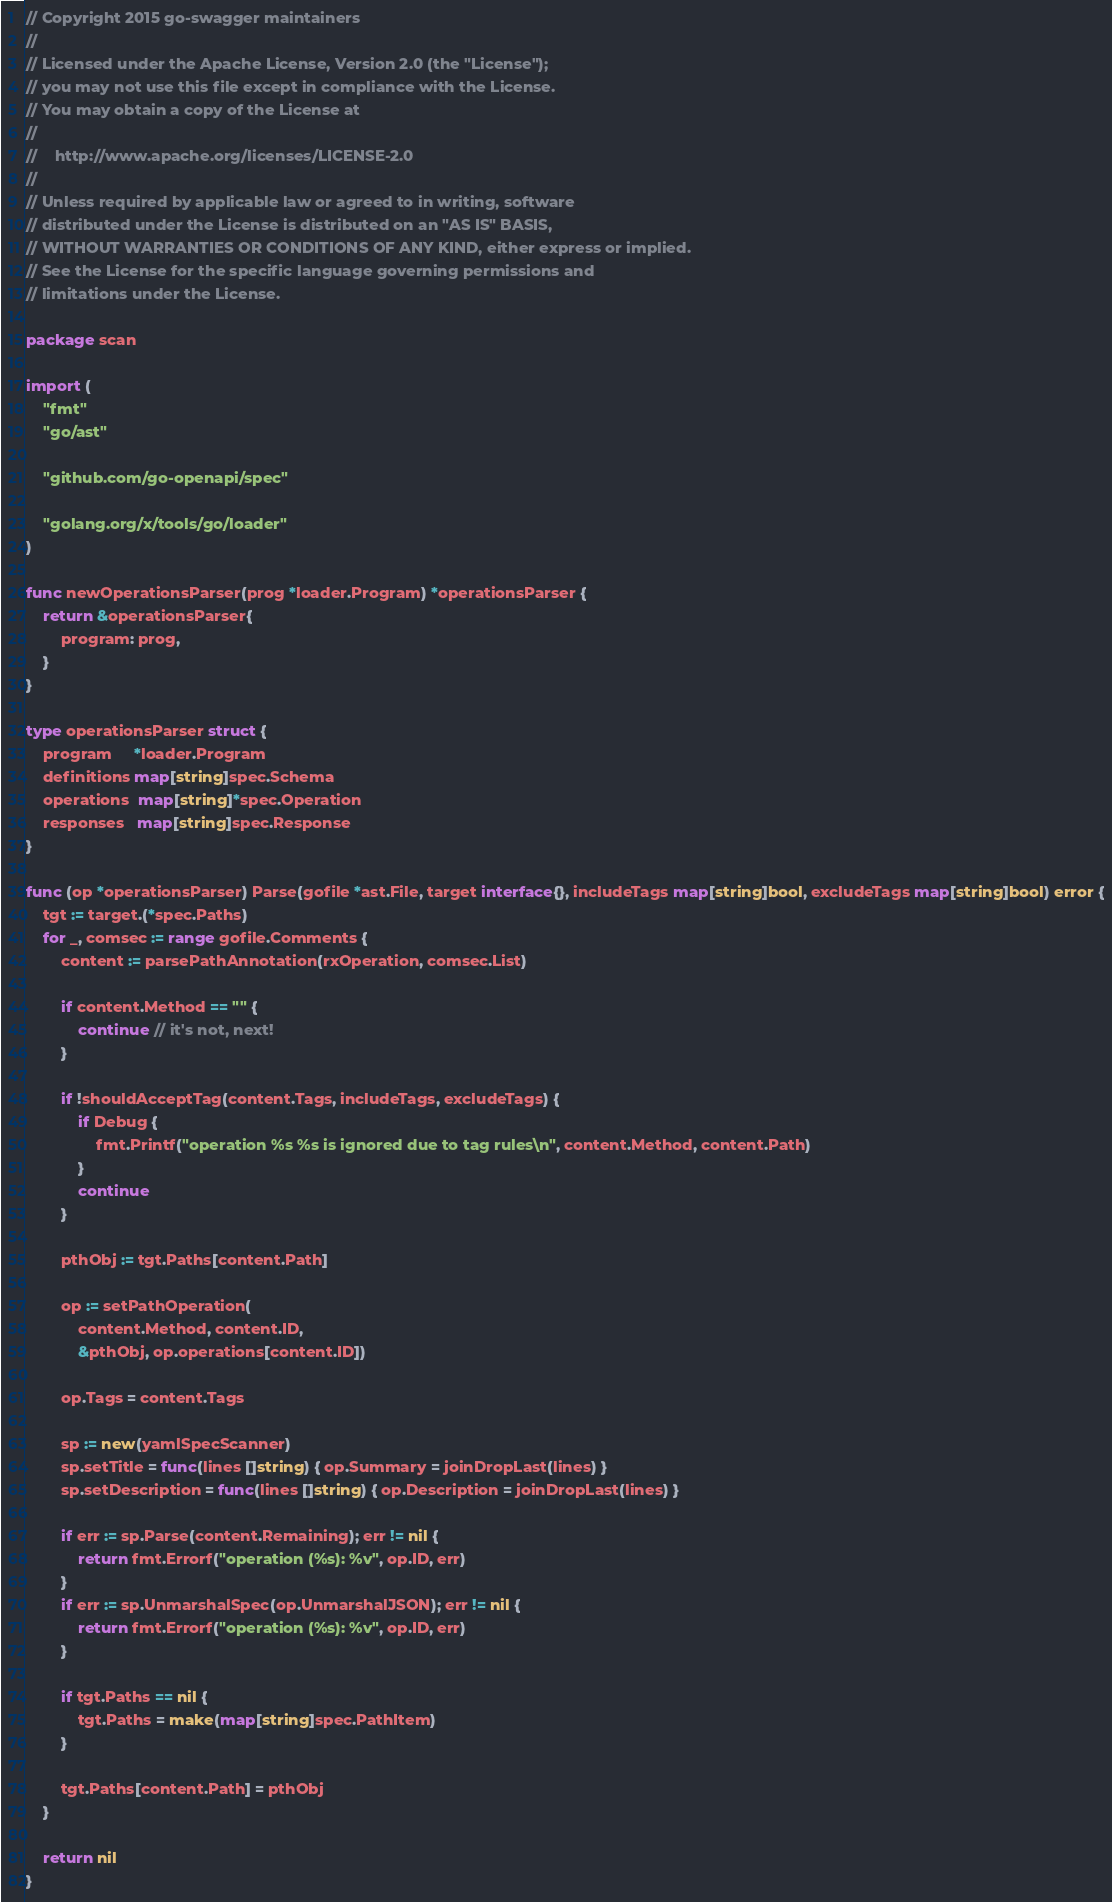<code> <loc_0><loc_0><loc_500><loc_500><_Go_>// Copyright 2015 go-swagger maintainers
//
// Licensed under the Apache License, Version 2.0 (the "License");
// you may not use this file except in compliance with the License.
// You may obtain a copy of the License at
//
//    http://www.apache.org/licenses/LICENSE-2.0
//
// Unless required by applicable law or agreed to in writing, software
// distributed under the License is distributed on an "AS IS" BASIS,
// WITHOUT WARRANTIES OR CONDITIONS OF ANY KIND, either express or implied.
// See the License for the specific language governing permissions and
// limitations under the License.

package scan

import (
	"fmt"
	"go/ast"

	"github.com/go-openapi/spec"

	"golang.org/x/tools/go/loader"
)

func newOperationsParser(prog *loader.Program) *operationsParser {
	return &operationsParser{
		program: prog,
	}
}

type operationsParser struct {
	program     *loader.Program
	definitions map[string]spec.Schema
	operations  map[string]*spec.Operation
	responses   map[string]spec.Response
}

func (op *operationsParser) Parse(gofile *ast.File, target interface{}, includeTags map[string]bool, excludeTags map[string]bool) error {
	tgt := target.(*spec.Paths)
	for _, comsec := range gofile.Comments {
		content := parsePathAnnotation(rxOperation, comsec.List)

		if content.Method == "" {
			continue // it's not, next!
		}

		if !shouldAcceptTag(content.Tags, includeTags, excludeTags) {
			if Debug {
				fmt.Printf("operation %s %s is ignored due to tag rules\n", content.Method, content.Path)
			}
			continue
		}

		pthObj := tgt.Paths[content.Path]

		op := setPathOperation(
			content.Method, content.ID,
			&pthObj, op.operations[content.ID])

		op.Tags = content.Tags

		sp := new(yamlSpecScanner)
		sp.setTitle = func(lines []string) { op.Summary = joinDropLast(lines) }
		sp.setDescription = func(lines []string) { op.Description = joinDropLast(lines) }

		if err := sp.Parse(content.Remaining); err != nil {
			return fmt.Errorf("operation (%s): %v", op.ID, err)
		}
		if err := sp.UnmarshalSpec(op.UnmarshalJSON); err != nil {
			return fmt.Errorf("operation (%s): %v", op.ID, err)
		}

		if tgt.Paths == nil {
			tgt.Paths = make(map[string]spec.PathItem)
		}

		tgt.Paths[content.Path] = pthObj
	}

	return nil
}
</code> 